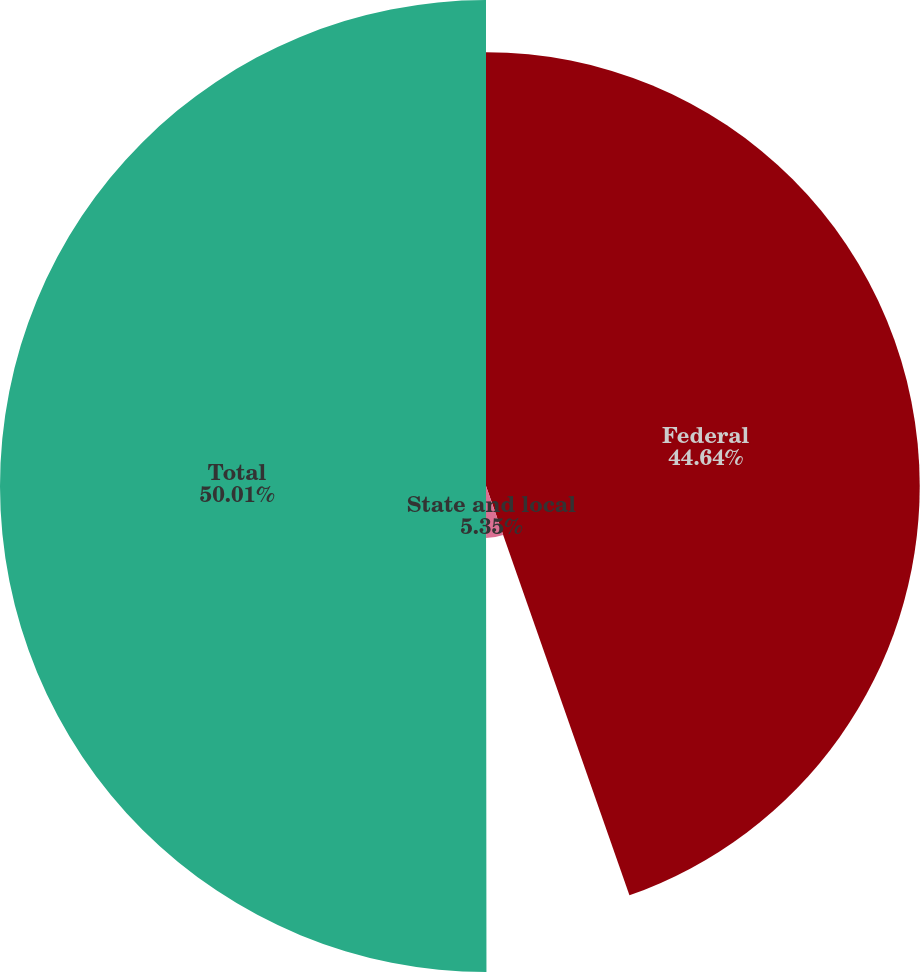Convert chart. <chart><loc_0><loc_0><loc_500><loc_500><pie_chart><fcel>Federal<fcel>State and local<fcel>Total<nl><fcel>44.64%<fcel>5.35%<fcel>50.02%<nl></chart> 